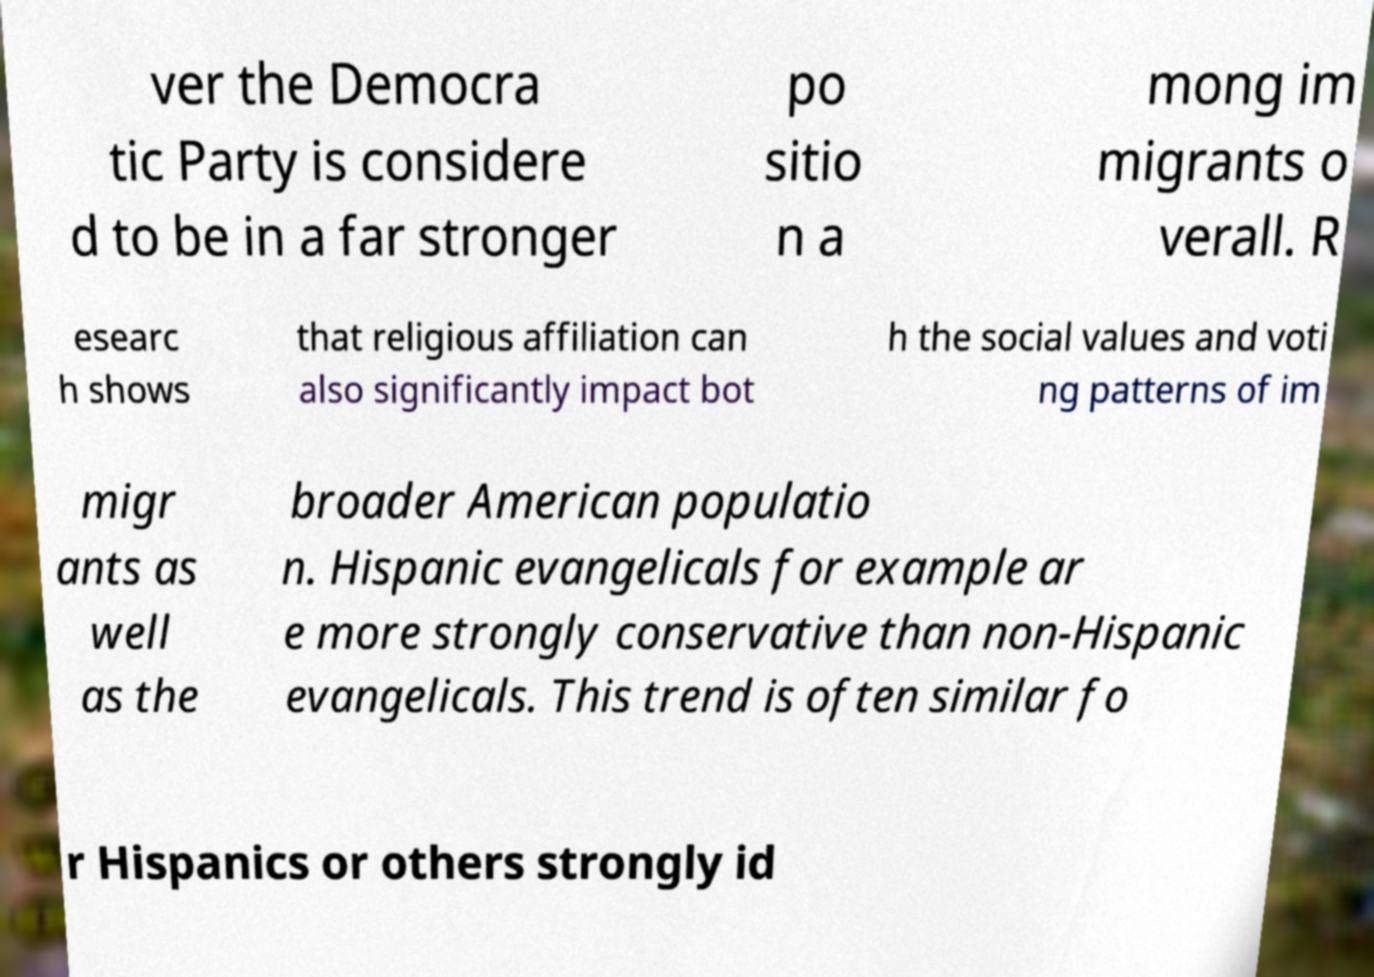Can you read and provide the text displayed in the image?This photo seems to have some interesting text. Can you extract and type it out for me? ver the Democra tic Party is considere d to be in a far stronger po sitio n a mong im migrants o verall. R esearc h shows that religious affiliation can also significantly impact bot h the social values and voti ng patterns of im migr ants as well as the broader American populatio n. Hispanic evangelicals for example ar e more strongly conservative than non-Hispanic evangelicals. This trend is often similar fo r Hispanics or others strongly id 